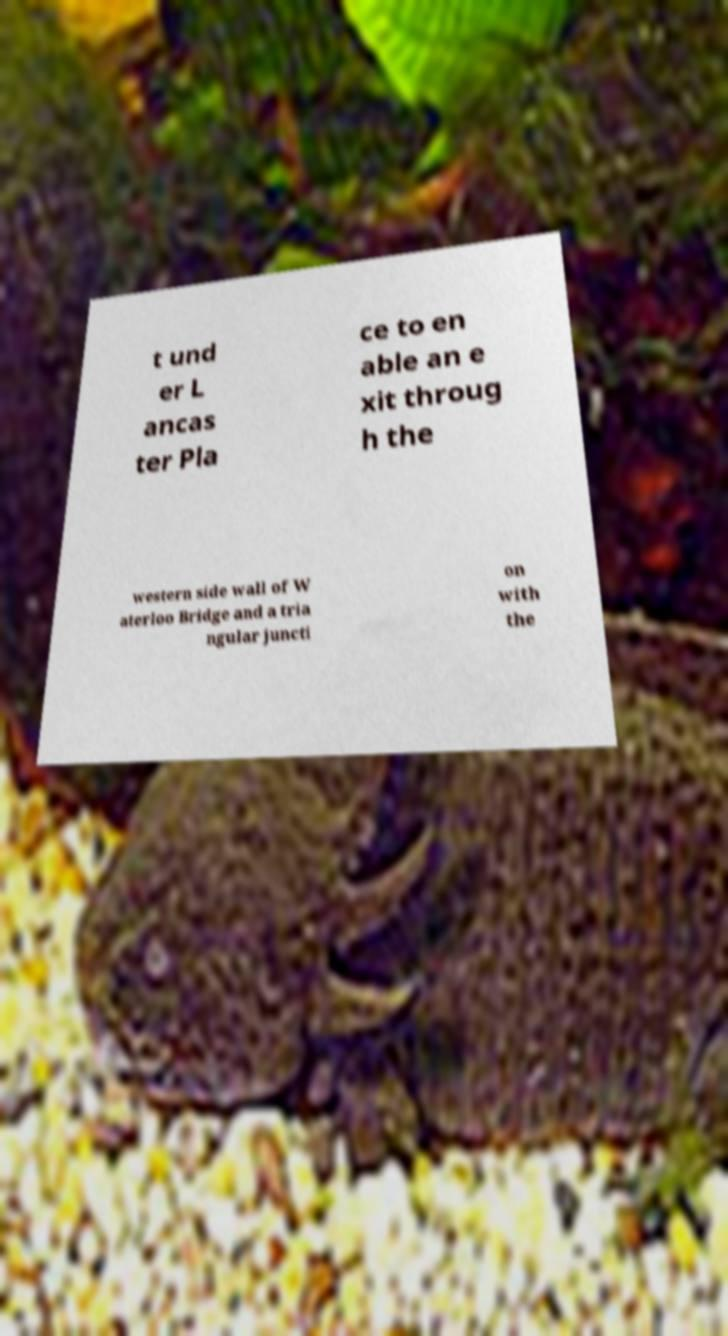Can you read and provide the text displayed in the image?This photo seems to have some interesting text. Can you extract and type it out for me? t und er L ancas ter Pla ce to en able an e xit throug h the western side wall of W aterloo Bridge and a tria ngular juncti on with the 